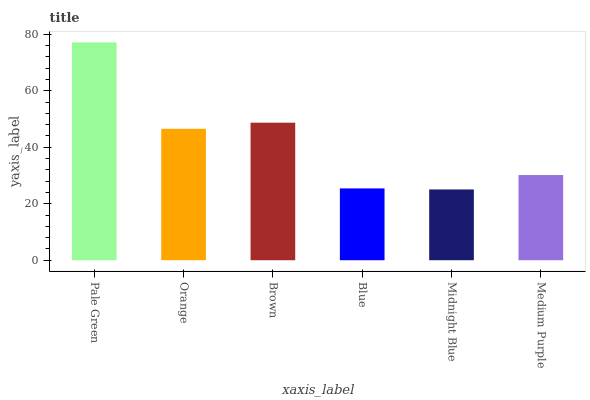Is Midnight Blue the minimum?
Answer yes or no. Yes. Is Pale Green the maximum?
Answer yes or no. Yes. Is Orange the minimum?
Answer yes or no. No. Is Orange the maximum?
Answer yes or no. No. Is Pale Green greater than Orange?
Answer yes or no. Yes. Is Orange less than Pale Green?
Answer yes or no. Yes. Is Orange greater than Pale Green?
Answer yes or no. No. Is Pale Green less than Orange?
Answer yes or no. No. Is Orange the high median?
Answer yes or no. Yes. Is Medium Purple the low median?
Answer yes or no. Yes. Is Midnight Blue the high median?
Answer yes or no. No. Is Orange the low median?
Answer yes or no. No. 